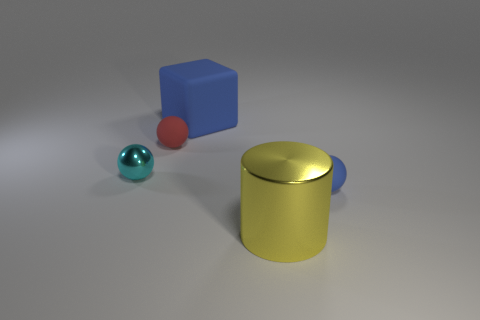The red sphere is what size? The red sphere appears significantly smaller compared to the other objects in the image, like the blue cube and the yellow cylinder. It could be described as quite small, especially next to the cylinder which is the largest object. 